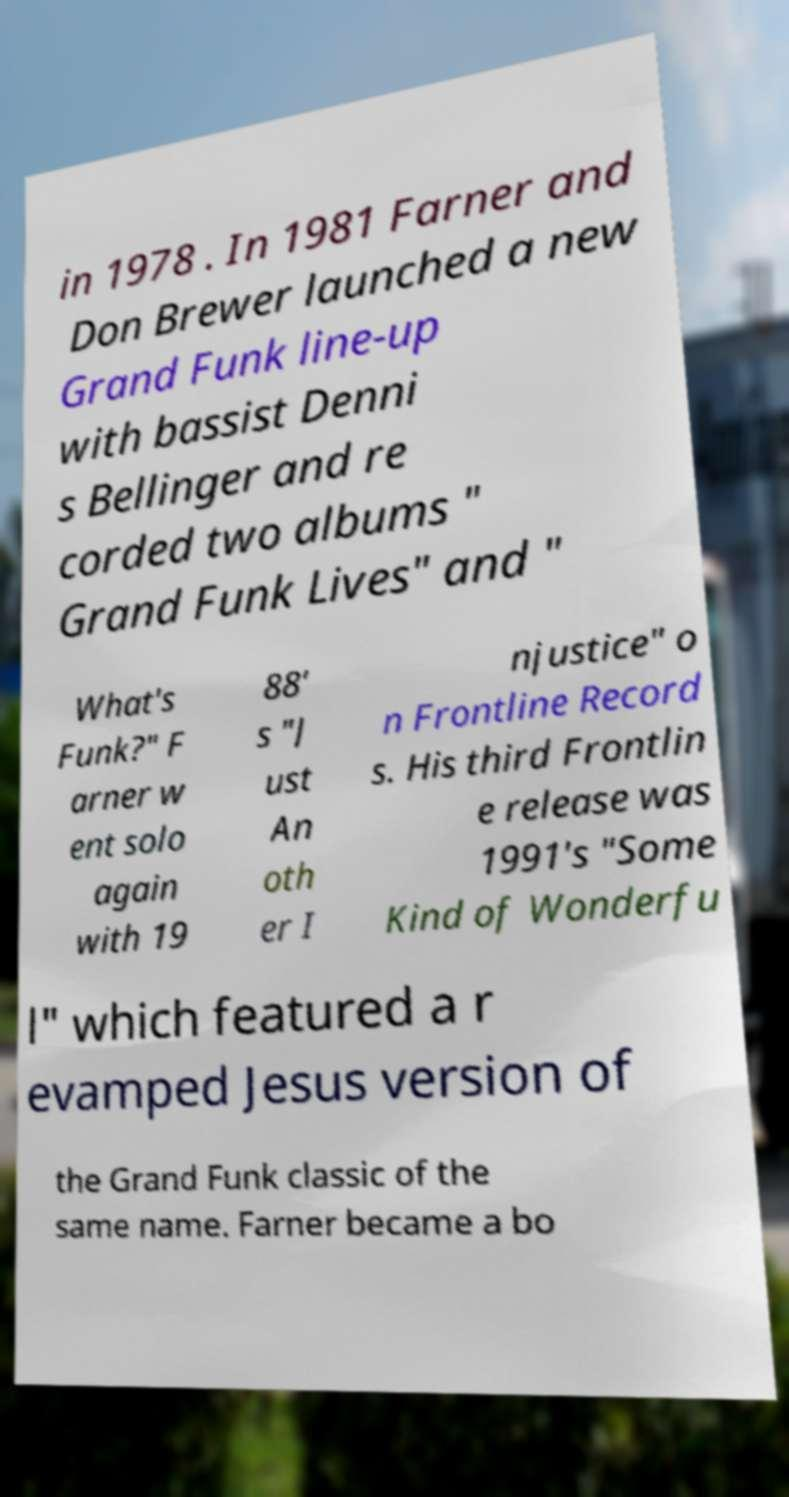Please identify and transcribe the text found in this image. in 1978 . In 1981 Farner and Don Brewer launched a new Grand Funk line-up with bassist Denni s Bellinger and re corded two albums " Grand Funk Lives" and " What's Funk?" F arner w ent solo again with 19 88' s "J ust An oth er I njustice" o n Frontline Record s. His third Frontlin e release was 1991's "Some Kind of Wonderfu l" which featured a r evamped Jesus version of the Grand Funk classic of the same name. Farner became a bo 